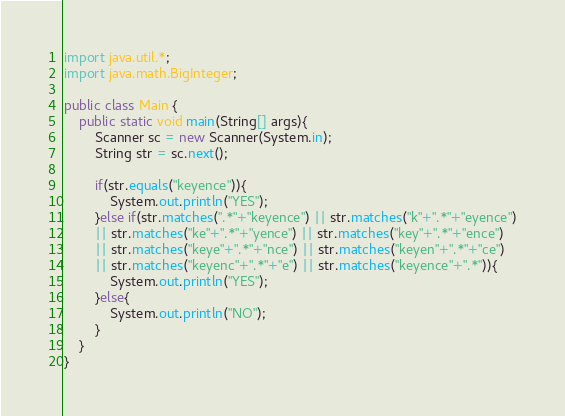<code> <loc_0><loc_0><loc_500><loc_500><_Java_>import java.util.*;
import java.math.BigInteger;

public class Main {
    public static void main(String[] args){
        Scanner sc = new Scanner(System.in);
        String str = sc.next();
        
        if(str.equals("keyence")){
            System.out.println("YES");
        }else if(str.matches(".*"+"keyence") || str.matches("k"+".*"+"eyence")
        || str.matches("ke"+".*"+"yence") || str.matches("key"+".*"+"ence")
        || str.matches("keye"+".*"+"nce") || str.matches("keyen"+".*"+"ce")
        || str.matches("keyenc"+".*"+"e") || str.matches("keyence"+".*")){
            System.out.println("YES");
        }else{
            System.out.println("NO");
        }
    }
}
</code> 